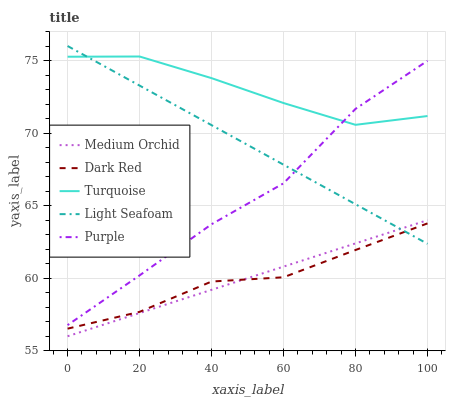Does Dark Red have the minimum area under the curve?
Answer yes or no. Yes. Does Turquoise have the maximum area under the curve?
Answer yes or no. Yes. Does Turquoise have the minimum area under the curve?
Answer yes or no. No. Does Dark Red have the maximum area under the curve?
Answer yes or no. No. Is Medium Orchid the smoothest?
Answer yes or no. Yes. Is Purple the roughest?
Answer yes or no. Yes. Is Dark Red the smoothest?
Answer yes or no. No. Is Dark Red the roughest?
Answer yes or no. No. Does Medium Orchid have the lowest value?
Answer yes or no. Yes. Does Dark Red have the lowest value?
Answer yes or no. No. Does Light Seafoam have the highest value?
Answer yes or no. Yes. Does Turquoise have the highest value?
Answer yes or no. No. Is Medium Orchid less than Purple?
Answer yes or no. Yes. Is Purple greater than Medium Orchid?
Answer yes or no. Yes. Does Purple intersect Light Seafoam?
Answer yes or no. Yes. Is Purple less than Light Seafoam?
Answer yes or no. No. Is Purple greater than Light Seafoam?
Answer yes or no. No. Does Medium Orchid intersect Purple?
Answer yes or no. No. 